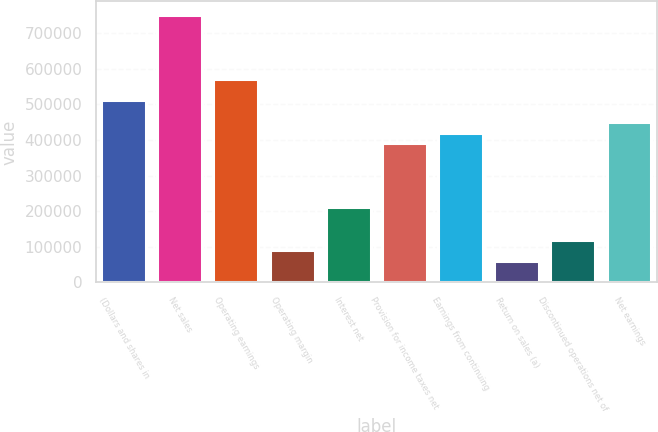Convert chart to OTSL. <chart><loc_0><loc_0><loc_500><loc_500><bar_chart><fcel>(Dollars and shares in<fcel>Net sales<fcel>Operating earnings<fcel>Operating margin<fcel>Interest net<fcel>Provision for income taxes net<fcel>Earnings from continuing<fcel>Return on sales (a)<fcel>Discontinued operations net of<fcel>Net earnings<nl><fcel>511189<fcel>751749<fcel>571329<fcel>90210.6<fcel>210490<fcel>390910<fcel>420980<fcel>60140.6<fcel>120280<fcel>451050<nl></chart> 